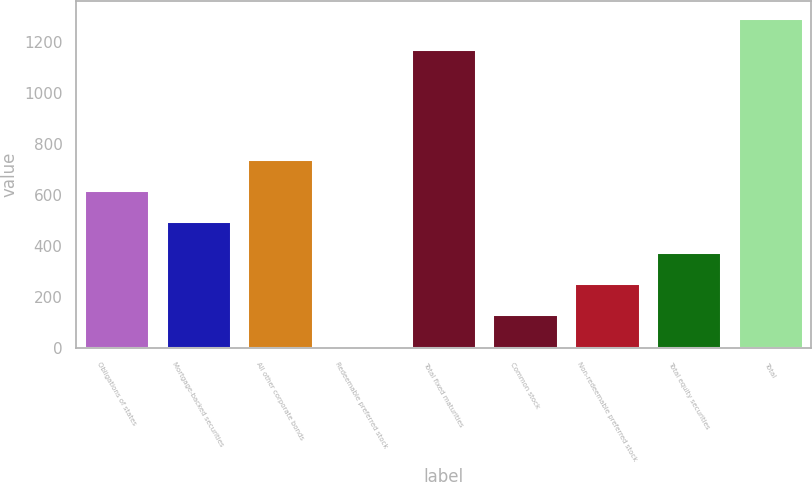Convert chart to OTSL. <chart><loc_0><loc_0><loc_500><loc_500><bar_chart><fcel>Obligations of states<fcel>Mortgage-backed securities<fcel>All other corporate bonds<fcel>Redeemable preferred stock<fcel>Total fixed maturities<fcel>Common stock<fcel>Non-redeemable preferred stock<fcel>Total equity securities<fcel>Total<nl><fcel>618<fcel>496.6<fcel>739.4<fcel>11<fcel>1172<fcel>132.4<fcel>253.8<fcel>375.2<fcel>1293.4<nl></chart> 